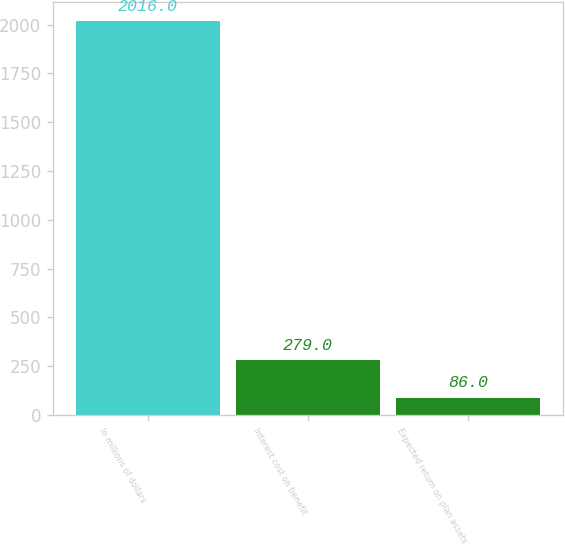Convert chart to OTSL. <chart><loc_0><loc_0><loc_500><loc_500><bar_chart><fcel>In millions of dollars<fcel>Interest cost on benefit<fcel>Expected return on plan assets<nl><fcel>2016<fcel>279<fcel>86<nl></chart> 